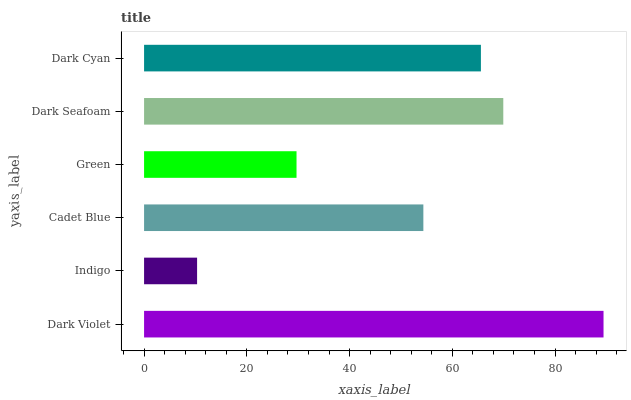Is Indigo the minimum?
Answer yes or no. Yes. Is Dark Violet the maximum?
Answer yes or no. Yes. Is Cadet Blue the minimum?
Answer yes or no. No. Is Cadet Blue the maximum?
Answer yes or no. No. Is Cadet Blue greater than Indigo?
Answer yes or no. Yes. Is Indigo less than Cadet Blue?
Answer yes or no. Yes. Is Indigo greater than Cadet Blue?
Answer yes or no. No. Is Cadet Blue less than Indigo?
Answer yes or no. No. Is Dark Cyan the high median?
Answer yes or no. Yes. Is Cadet Blue the low median?
Answer yes or no. Yes. Is Dark Violet the high median?
Answer yes or no. No. Is Dark Seafoam the low median?
Answer yes or no. No. 